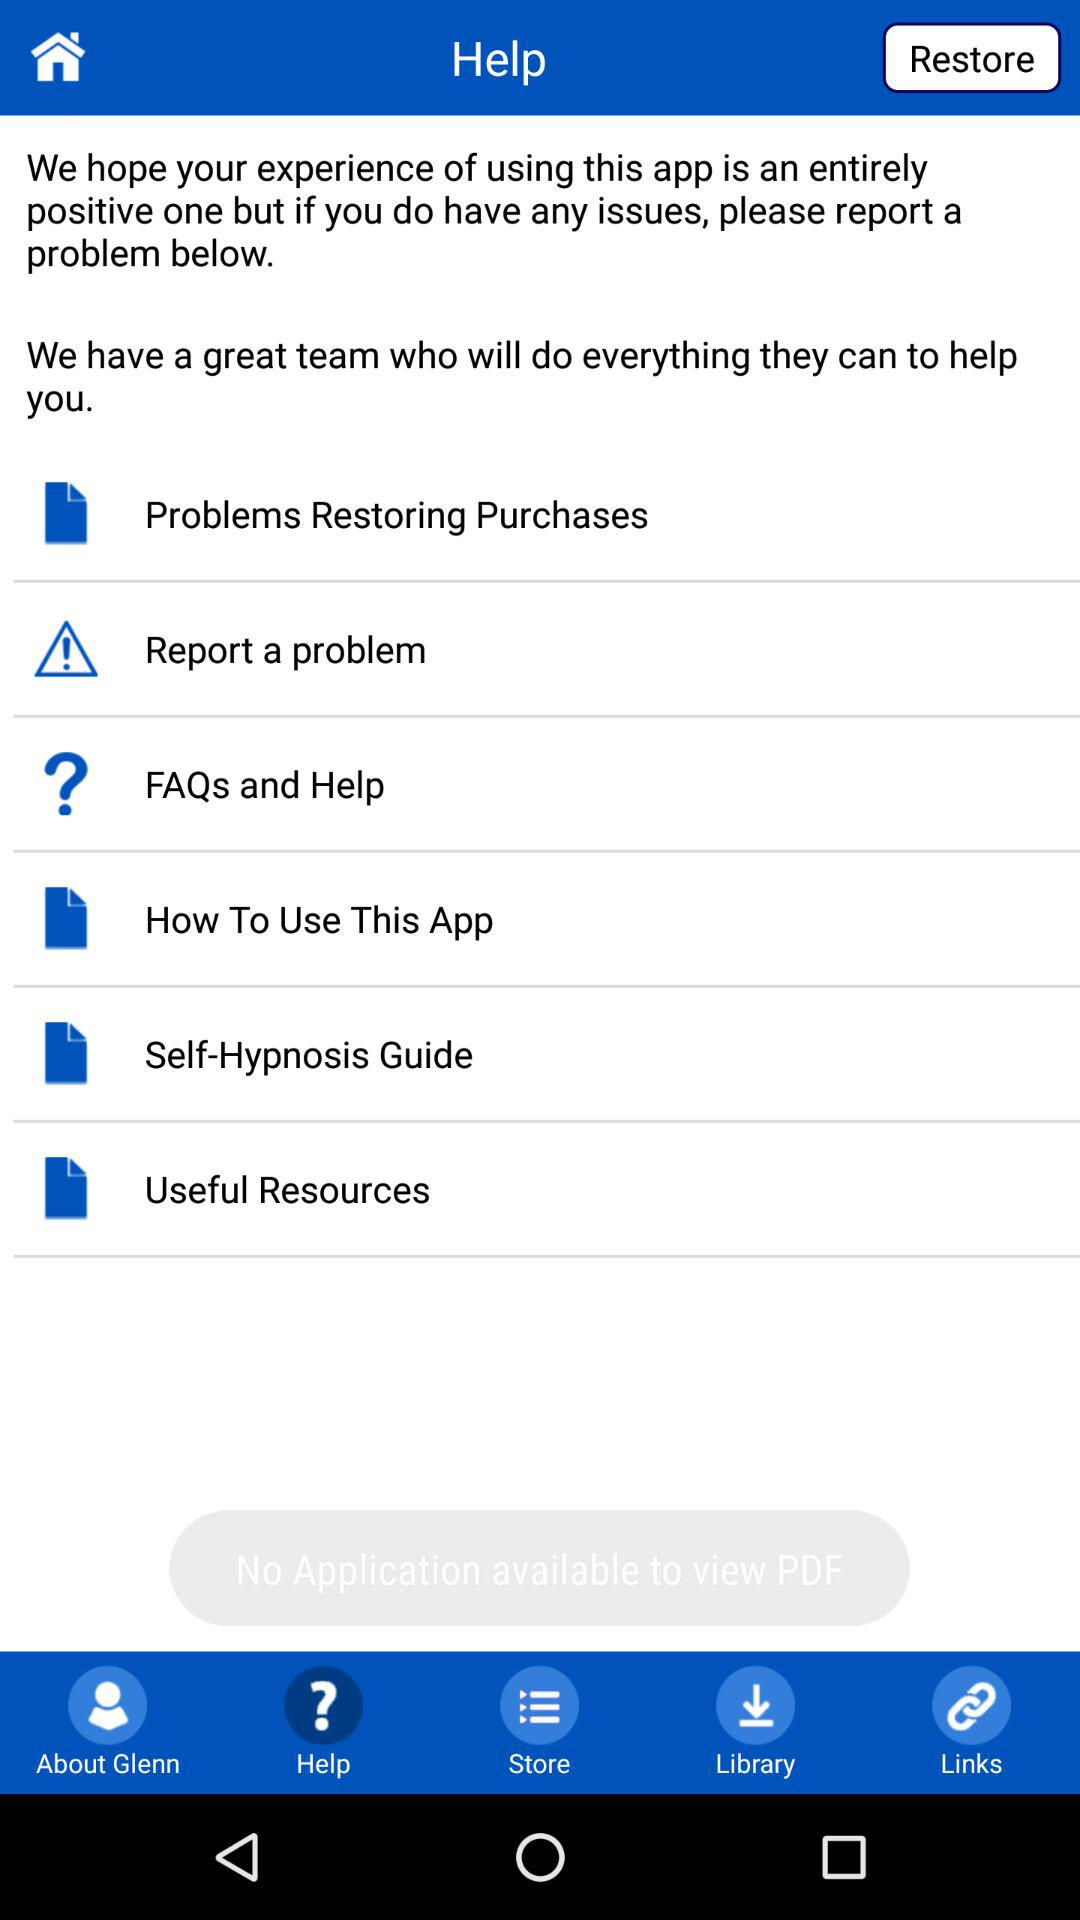Which questions are the most frequently asked?
When the provided information is insufficient, respond with <no answer>. <no answer> 